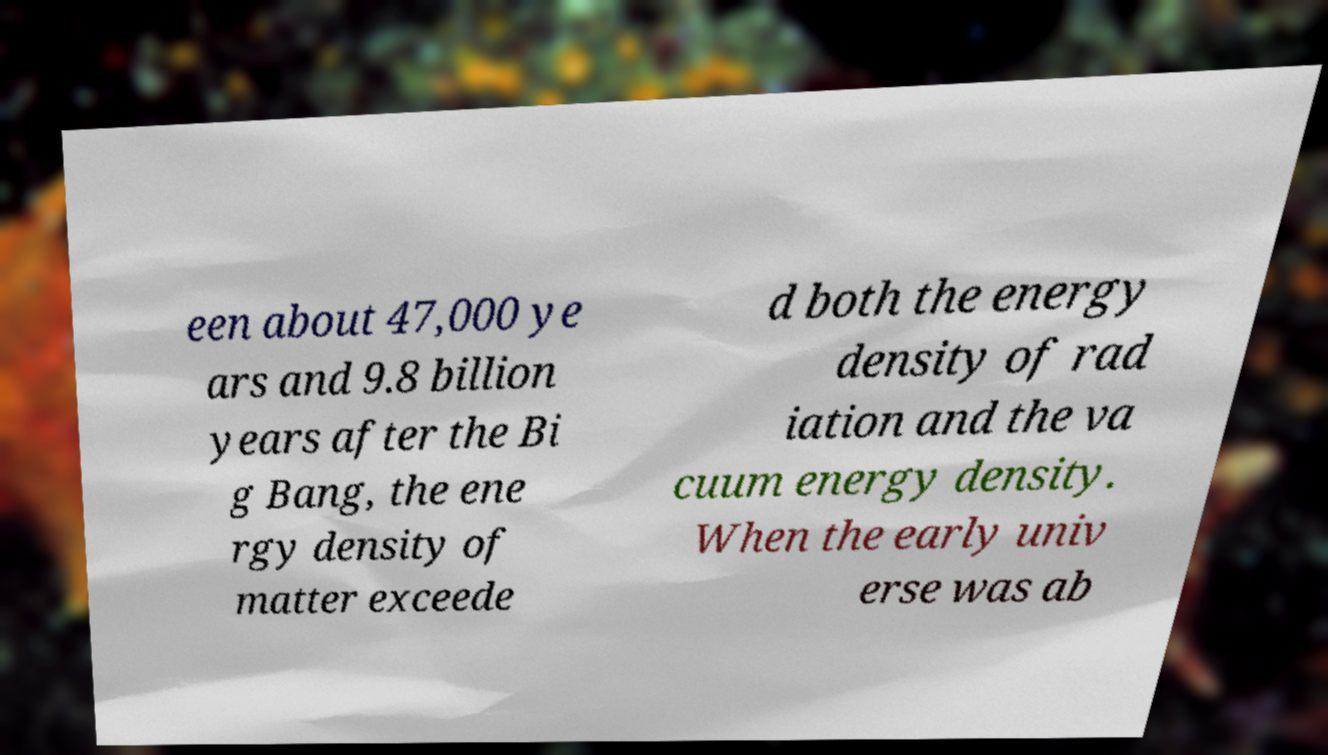Can you accurately transcribe the text from the provided image for me? een about 47,000 ye ars and 9.8 billion years after the Bi g Bang, the ene rgy density of matter exceede d both the energy density of rad iation and the va cuum energy density. When the early univ erse was ab 